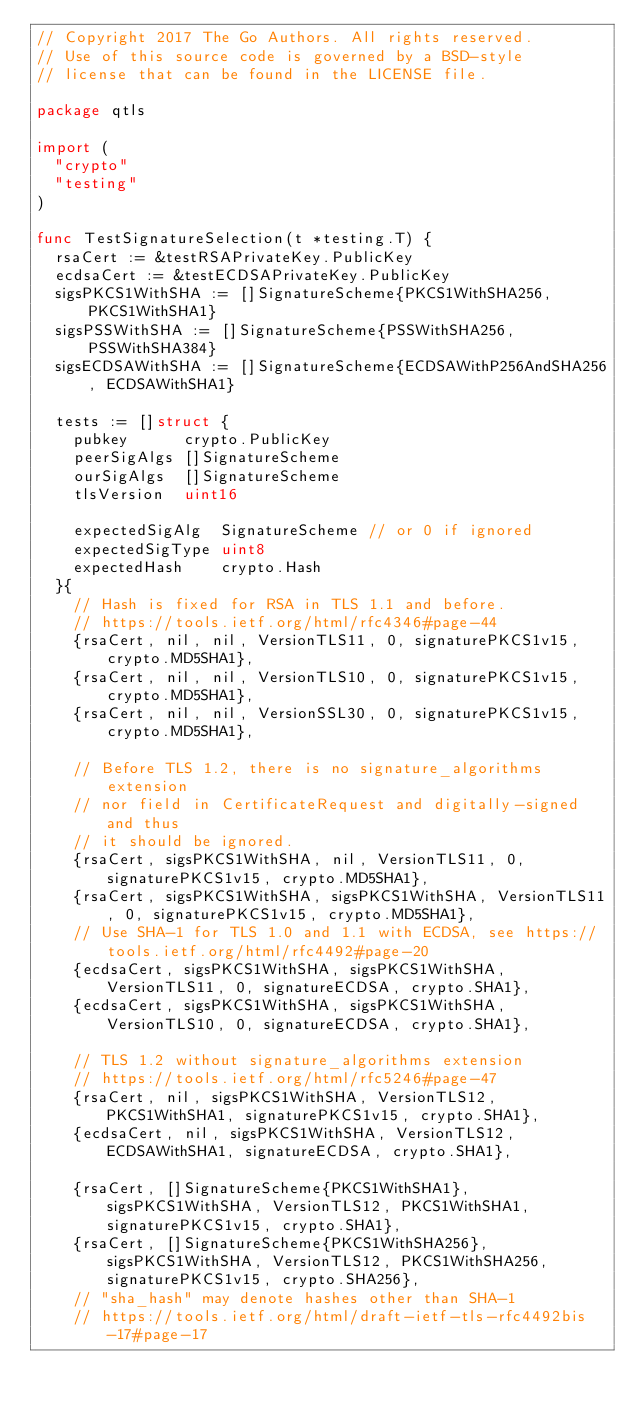<code> <loc_0><loc_0><loc_500><loc_500><_Go_>// Copyright 2017 The Go Authors. All rights reserved.
// Use of this source code is governed by a BSD-style
// license that can be found in the LICENSE file.

package qtls

import (
	"crypto"
	"testing"
)

func TestSignatureSelection(t *testing.T) {
	rsaCert := &testRSAPrivateKey.PublicKey
	ecdsaCert := &testECDSAPrivateKey.PublicKey
	sigsPKCS1WithSHA := []SignatureScheme{PKCS1WithSHA256, PKCS1WithSHA1}
	sigsPSSWithSHA := []SignatureScheme{PSSWithSHA256, PSSWithSHA384}
	sigsECDSAWithSHA := []SignatureScheme{ECDSAWithP256AndSHA256, ECDSAWithSHA1}

	tests := []struct {
		pubkey      crypto.PublicKey
		peerSigAlgs []SignatureScheme
		ourSigAlgs  []SignatureScheme
		tlsVersion  uint16

		expectedSigAlg  SignatureScheme // or 0 if ignored
		expectedSigType uint8
		expectedHash    crypto.Hash
	}{
		// Hash is fixed for RSA in TLS 1.1 and before.
		// https://tools.ietf.org/html/rfc4346#page-44
		{rsaCert, nil, nil, VersionTLS11, 0, signaturePKCS1v15, crypto.MD5SHA1},
		{rsaCert, nil, nil, VersionTLS10, 0, signaturePKCS1v15, crypto.MD5SHA1},
		{rsaCert, nil, nil, VersionSSL30, 0, signaturePKCS1v15, crypto.MD5SHA1},

		// Before TLS 1.2, there is no signature_algorithms extension
		// nor field in CertificateRequest and digitally-signed and thus
		// it should be ignored.
		{rsaCert, sigsPKCS1WithSHA, nil, VersionTLS11, 0, signaturePKCS1v15, crypto.MD5SHA1},
		{rsaCert, sigsPKCS1WithSHA, sigsPKCS1WithSHA, VersionTLS11, 0, signaturePKCS1v15, crypto.MD5SHA1},
		// Use SHA-1 for TLS 1.0 and 1.1 with ECDSA, see https://tools.ietf.org/html/rfc4492#page-20
		{ecdsaCert, sigsPKCS1WithSHA, sigsPKCS1WithSHA, VersionTLS11, 0, signatureECDSA, crypto.SHA1},
		{ecdsaCert, sigsPKCS1WithSHA, sigsPKCS1WithSHA, VersionTLS10, 0, signatureECDSA, crypto.SHA1},

		// TLS 1.2 without signature_algorithms extension
		// https://tools.ietf.org/html/rfc5246#page-47
		{rsaCert, nil, sigsPKCS1WithSHA, VersionTLS12, PKCS1WithSHA1, signaturePKCS1v15, crypto.SHA1},
		{ecdsaCert, nil, sigsPKCS1WithSHA, VersionTLS12, ECDSAWithSHA1, signatureECDSA, crypto.SHA1},

		{rsaCert, []SignatureScheme{PKCS1WithSHA1}, sigsPKCS1WithSHA, VersionTLS12, PKCS1WithSHA1, signaturePKCS1v15, crypto.SHA1},
		{rsaCert, []SignatureScheme{PKCS1WithSHA256}, sigsPKCS1WithSHA, VersionTLS12, PKCS1WithSHA256, signaturePKCS1v15, crypto.SHA256},
		// "sha_hash" may denote hashes other than SHA-1
		// https://tools.ietf.org/html/draft-ietf-tls-rfc4492bis-17#page-17</code> 